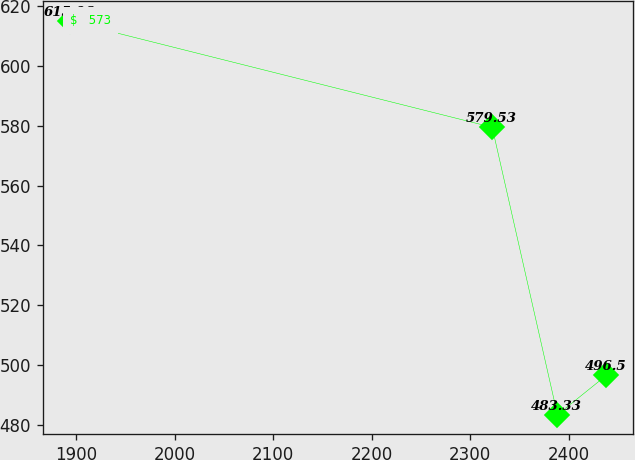Convert chart. <chart><loc_0><loc_0><loc_500><loc_500><line_chart><ecel><fcel>$   573<nl><fcel>1893.5<fcel>615.06<nl><fcel>2322.26<fcel>579.53<nl><fcel>2388.45<fcel>483.33<nl><fcel>2438.07<fcel>496.5<nl></chart> 